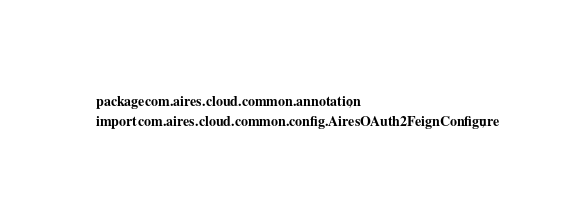<code> <loc_0><loc_0><loc_500><loc_500><_Java_>package com.aires.cloud.common.annotation;

import com.aires.cloud.common.config.AiresOAuth2FeignConfigure;</code> 